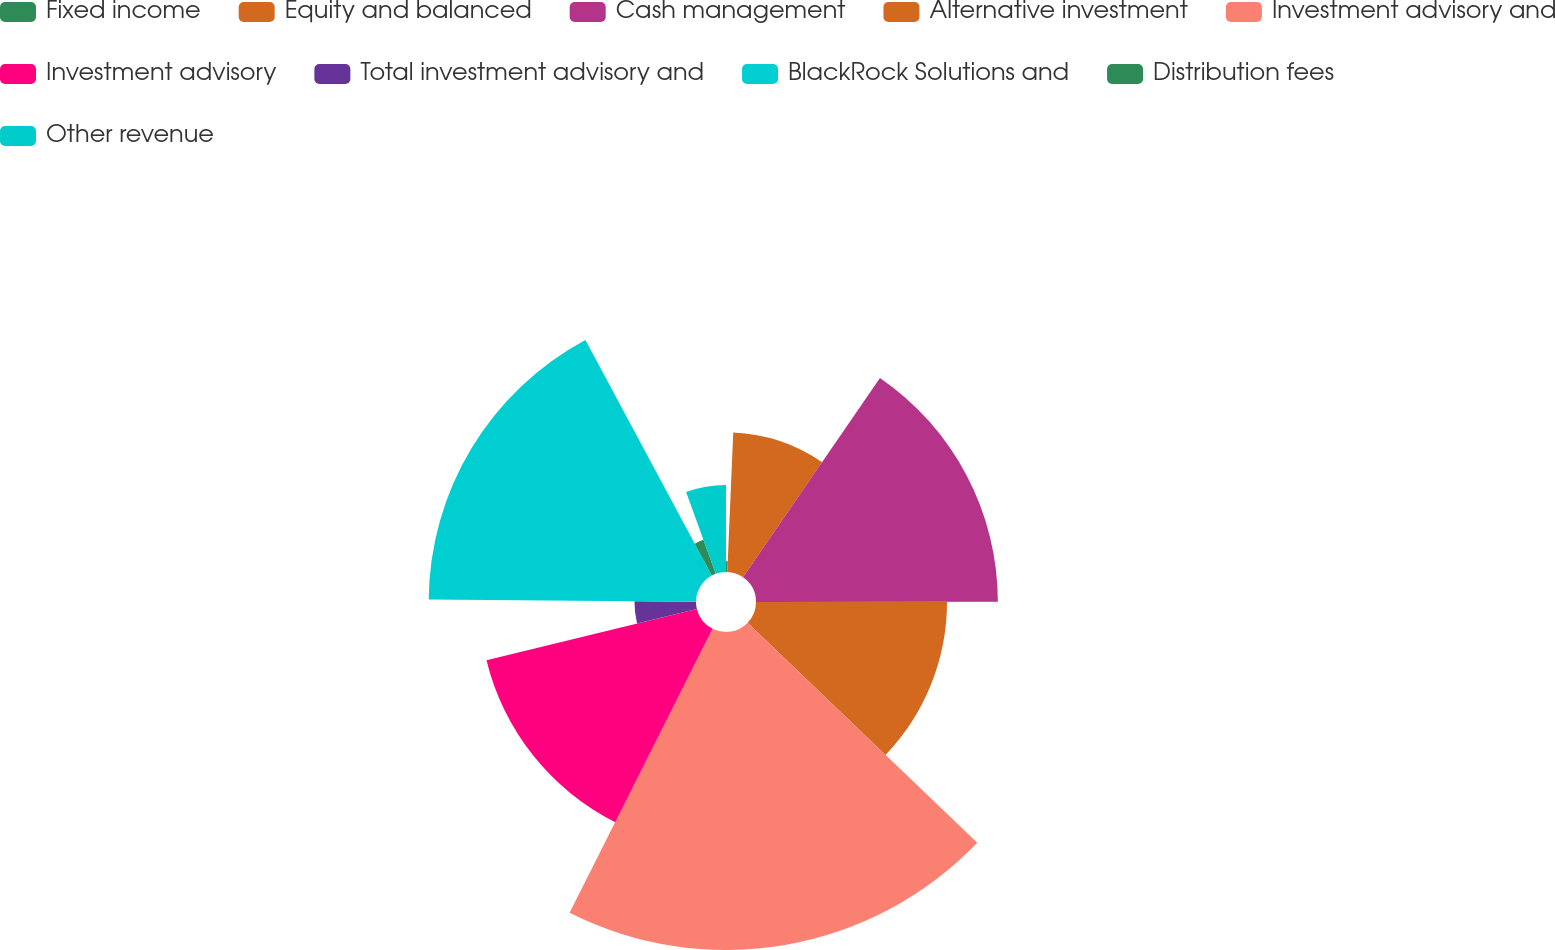Convert chart to OTSL. <chart><loc_0><loc_0><loc_500><loc_500><pie_chart><fcel>Fixed income<fcel>Equity and balanced<fcel>Cash management<fcel>Alternative investment<fcel>Investment advisory and<fcel>Investment advisory<fcel>Total investment advisory and<fcel>BlackRock Solutions and<fcel>Distribution fees<fcel>Other revenue<nl><fcel>0.68%<fcel>8.9%<fcel>15.41%<fcel>12.17%<fcel>20.26%<fcel>13.79%<fcel>3.92%<fcel>17.03%<fcel>2.3%<fcel>5.54%<nl></chart> 